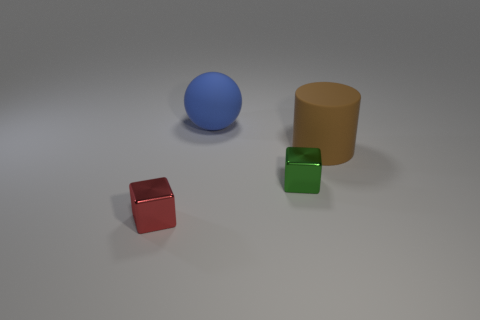Add 2 tiny yellow rubber things. How many objects exist? 6 Subtract all green cubes. How many cubes are left? 1 Subtract all cylinders. How many objects are left? 3 Subtract all red cubes. Subtract all yellow balls. How many cubes are left? 1 Subtract all small green objects. Subtract all large brown cylinders. How many objects are left? 2 Add 1 tiny cubes. How many tiny cubes are left? 3 Add 3 big cylinders. How many big cylinders exist? 4 Subtract 1 brown cylinders. How many objects are left? 3 